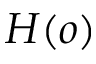<formula> <loc_0><loc_0><loc_500><loc_500>H ( o )</formula> 